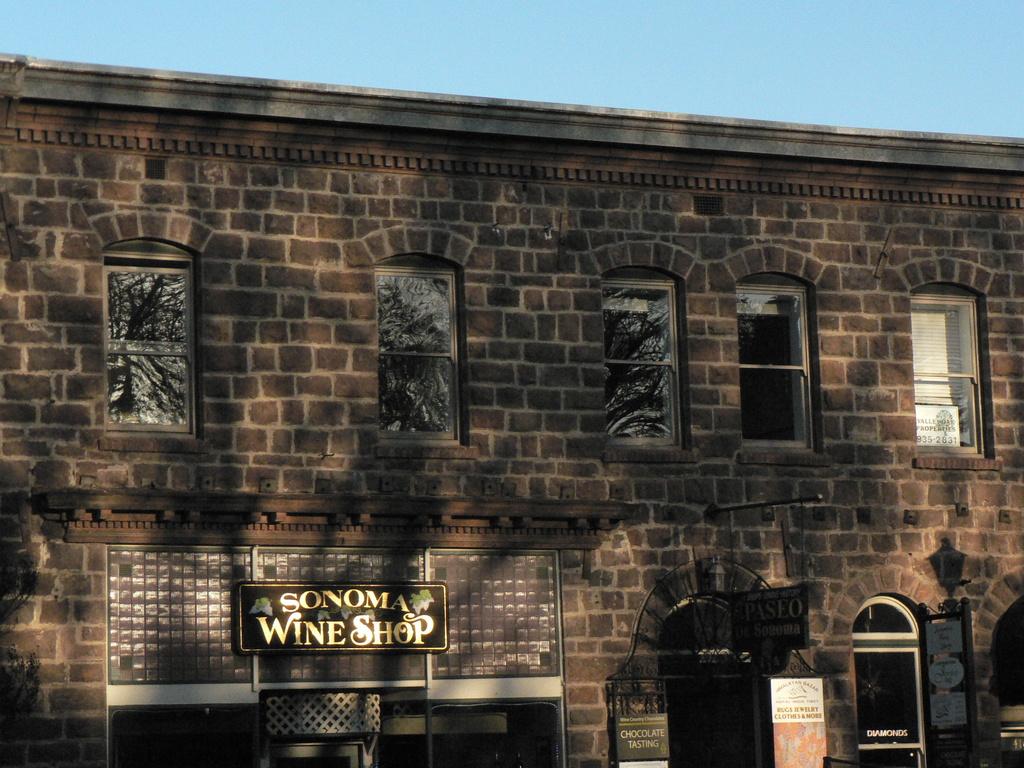What is sonom?
Offer a very short reply. Wine shop. What is the name of the shop?
Provide a succinct answer. Sonoma wine shop. 